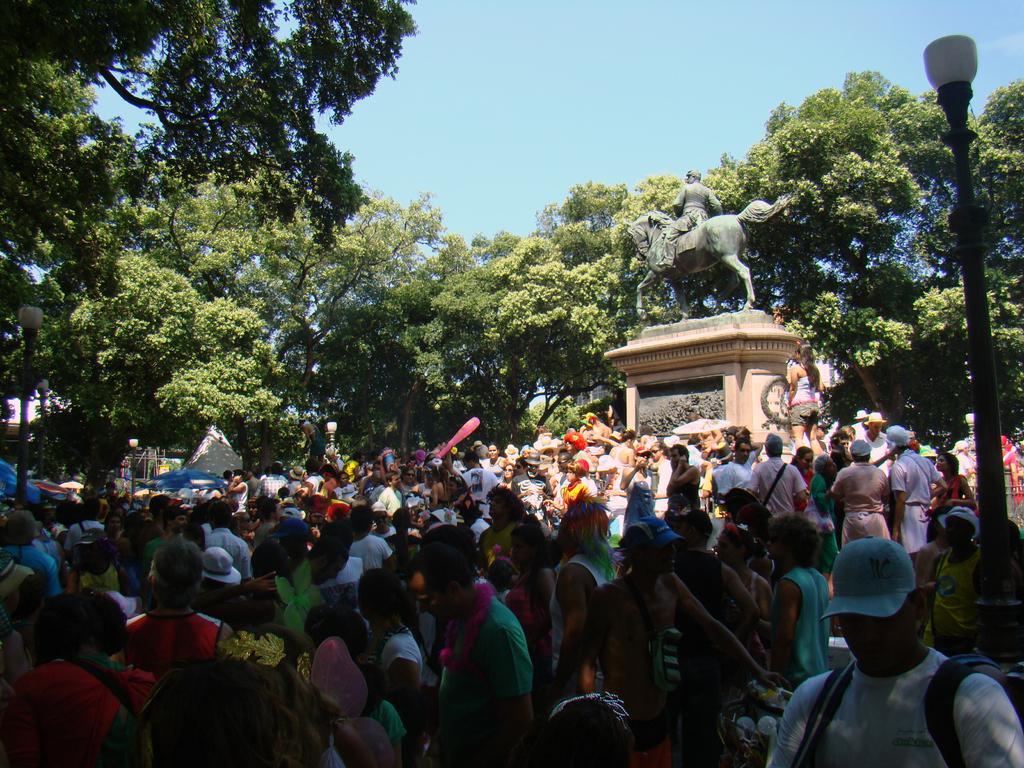Please provide a concise description of this image. In this image we can see a few people, few trees, a sculpture and few lights attached to the poles. 